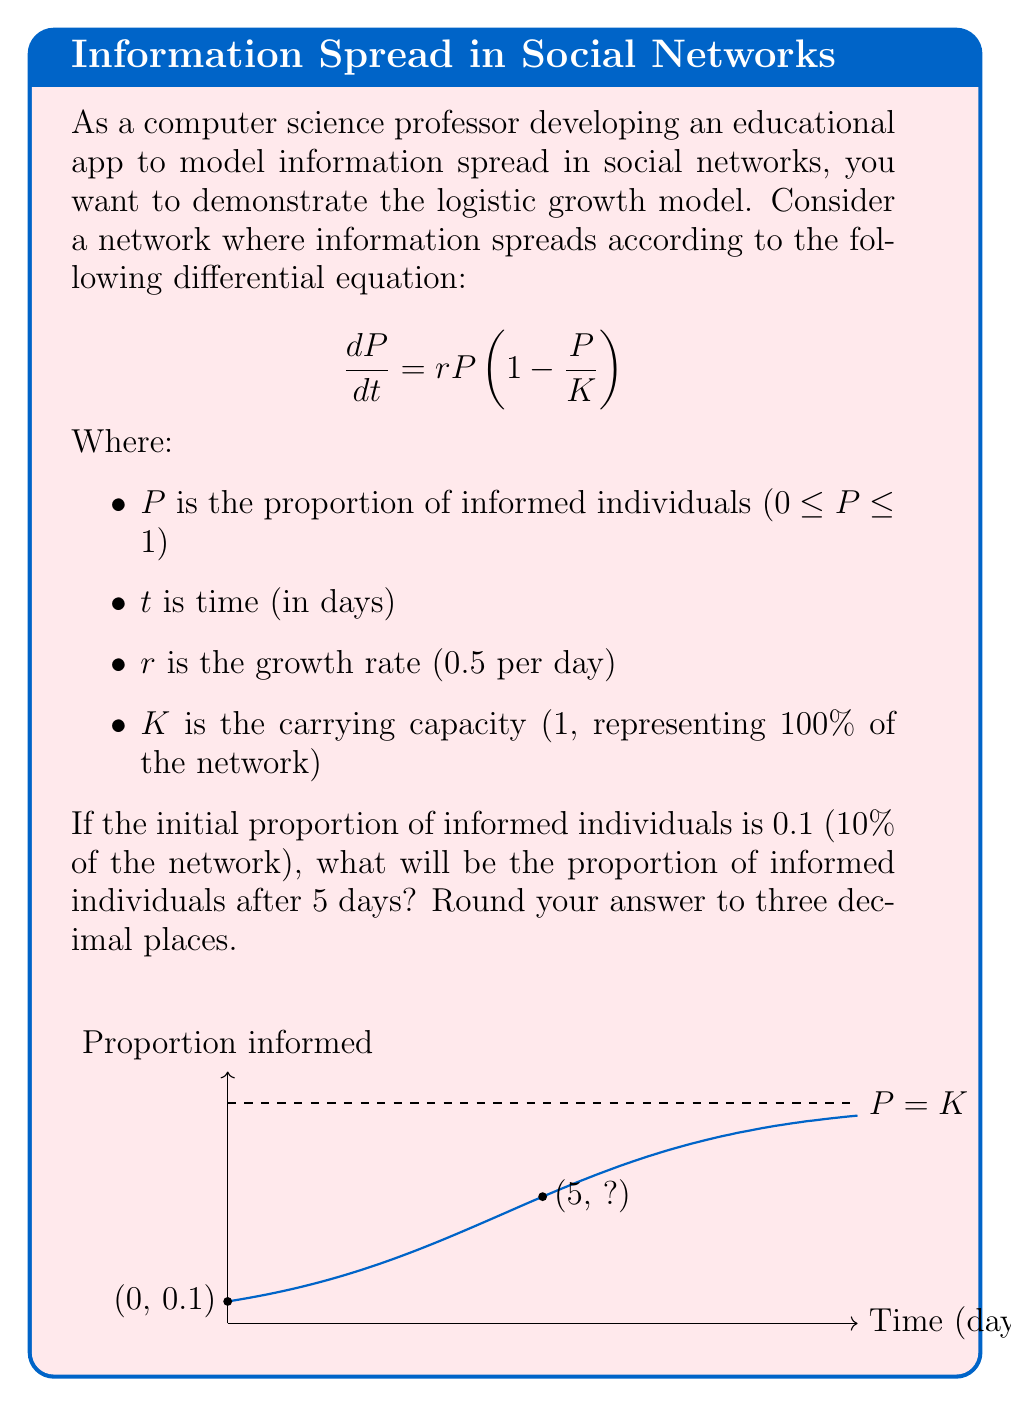Could you help me with this problem? To solve this problem, we need to use the solution to the logistic differential equation:

1) The general solution to the logistic equation is:

   $$P(t) = \frac{K}{1 + (\frac{K}{P_0} - 1)e^{-rt}}$$

   Where $P_0$ is the initial population.

2) We're given:
   - $K = 1$ (carrying capacity)
   - $r = 0.5$ (growth rate)
   - $P_0 = 0.1$ (initial proportion)
   - $t = 5$ (time we're interested in)

3) Let's substitute these values into our equation:

   $$P(5) = \frac{1}{1 + (\frac{1}{0.1} - 1)e^{-0.5 \cdot 5}}$$

4) Simplify:
   $$P(5) = \frac{1}{1 + (10 - 1)e^{-2.5}}$$
   $$P(5) = \frac{1}{1 + 9e^{-2.5}}$$

5) Calculate $e^{-2.5}$ ≈ 0.0821

6) Substitute this value:
   $$P(5) = \frac{1}{1 + 9 \cdot 0.0821} = \frac{1}{1 + 0.7389} = \frac{1}{1.7389}$$

7) Calculate the final result:
   $$P(5) \approx 0.5751$$

8) Rounding to three decimal places:
   $$P(5) \approx 0.575$$

Therefore, after 5 days, approximately 57.5% of the network will be informed.
Answer: 0.575 